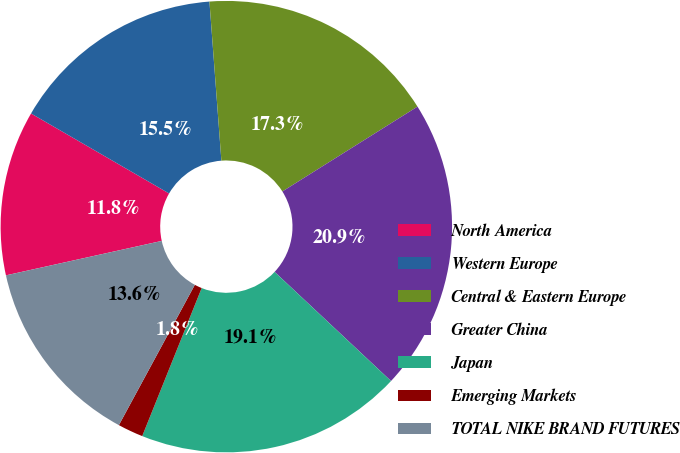Convert chart to OTSL. <chart><loc_0><loc_0><loc_500><loc_500><pie_chart><fcel>North America<fcel>Western Europe<fcel>Central & Eastern Europe<fcel>Greater China<fcel>Japan<fcel>Emerging Markets<fcel>TOTAL NIKE BRAND FUTURES<nl><fcel>11.82%<fcel>15.45%<fcel>17.27%<fcel>20.91%<fcel>19.09%<fcel>1.82%<fcel>13.64%<nl></chart> 